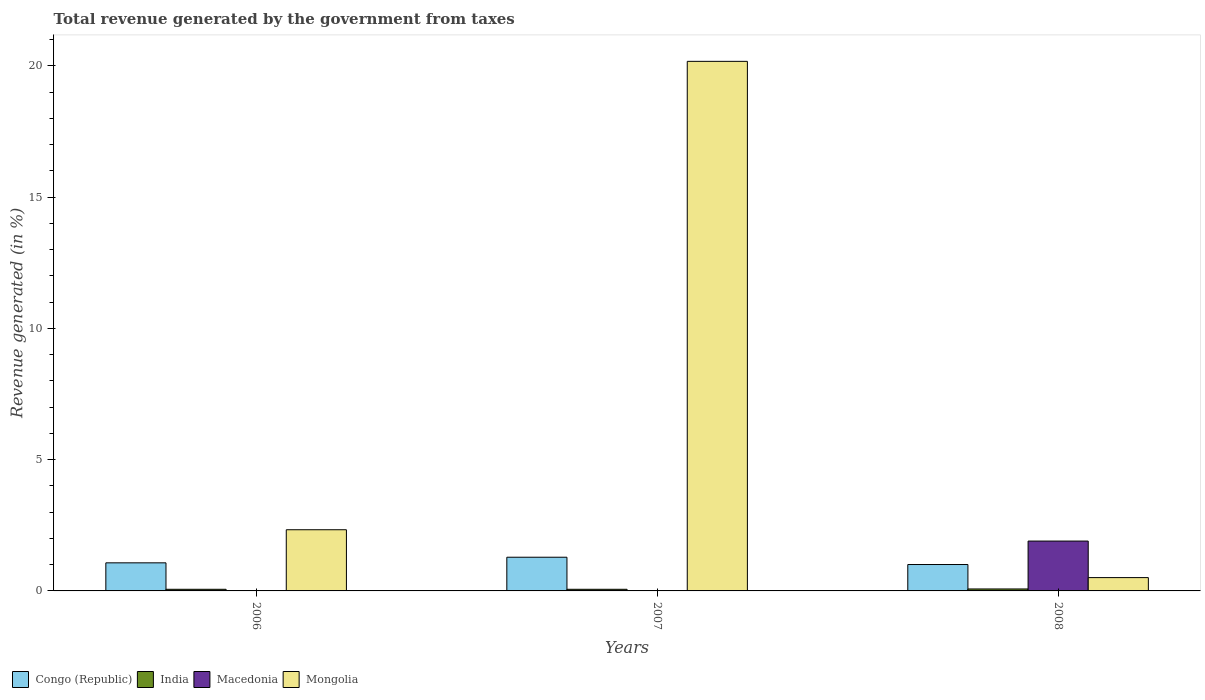How many different coloured bars are there?
Your answer should be very brief. 4. How many groups of bars are there?
Offer a very short reply. 3. Are the number of bars per tick equal to the number of legend labels?
Give a very brief answer. Yes. Are the number of bars on each tick of the X-axis equal?
Provide a succinct answer. Yes. How many bars are there on the 1st tick from the left?
Keep it short and to the point. 4. How many bars are there on the 2nd tick from the right?
Keep it short and to the point. 4. What is the label of the 3rd group of bars from the left?
Ensure brevity in your answer.  2008. What is the total revenue generated in Macedonia in 2007?
Provide a succinct answer. 0.01. Across all years, what is the maximum total revenue generated in Congo (Republic)?
Offer a terse response. 1.28. Across all years, what is the minimum total revenue generated in Mongolia?
Offer a terse response. 0.51. What is the total total revenue generated in Mongolia in the graph?
Your response must be concise. 23.01. What is the difference between the total revenue generated in Congo (Republic) in 2007 and that in 2008?
Ensure brevity in your answer.  0.28. What is the difference between the total revenue generated in Congo (Republic) in 2007 and the total revenue generated in Mongolia in 2008?
Your answer should be very brief. 0.78. What is the average total revenue generated in Congo (Republic) per year?
Your answer should be compact. 1.12. In the year 2006, what is the difference between the total revenue generated in Congo (Republic) and total revenue generated in Macedonia?
Offer a very short reply. 1.06. In how many years, is the total revenue generated in Mongolia greater than 3 %?
Offer a very short reply. 1. What is the ratio of the total revenue generated in Macedonia in 2007 to that in 2008?
Ensure brevity in your answer.  0. Is the total revenue generated in Congo (Republic) in 2006 less than that in 2008?
Provide a succinct answer. No. Is the difference between the total revenue generated in Congo (Republic) in 2007 and 2008 greater than the difference between the total revenue generated in Macedonia in 2007 and 2008?
Offer a very short reply. Yes. What is the difference between the highest and the second highest total revenue generated in Mongolia?
Offer a very short reply. 17.84. What is the difference between the highest and the lowest total revenue generated in India?
Provide a succinct answer. 0.01. In how many years, is the total revenue generated in India greater than the average total revenue generated in India taken over all years?
Make the answer very short. 1. Is it the case that in every year, the sum of the total revenue generated in Congo (Republic) and total revenue generated in Mongolia is greater than the sum of total revenue generated in India and total revenue generated in Macedonia?
Offer a very short reply. No. What does the 4th bar from the left in 2007 represents?
Give a very brief answer. Mongolia. What does the 2nd bar from the right in 2008 represents?
Provide a short and direct response. Macedonia. How many bars are there?
Keep it short and to the point. 12. Are all the bars in the graph horizontal?
Offer a very short reply. No. Are the values on the major ticks of Y-axis written in scientific E-notation?
Offer a terse response. No. Where does the legend appear in the graph?
Make the answer very short. Bottom left. How are the legend labels stacked?
Give a very brief answer. Horizontal. What is the title of the graph?
Your answer should be compact. Total revenue generated by the government from taxes. What is the label or title of the X-axis?
Offer a terse response. Years. What is the label or title of the Y-axis?
Keep it short and to the point. Revenue generated (in %). What is the Revenue generated (in %) in Congo (Republic) in 2006?
Provide a succinct answer. 1.07. What is the Revenue generated (in %) of India in 2006?
Give a very brief answer. 0.06. What is the Revenue generated (in %) in Macedonia in 2006?
Your answer should be very brief. 0.01. What is the Revenue generated (in %) of Mongolia in 2006?
Make the answer very short. 2.33. What is the Revenue generated (in %) of Congo (Republic) in 2007?
Offer a very short reply. 1.28. What is the Revenue generated (in %) of India in 2007?
Your response must be concise. 0.06. What is the Revenue generated (in %) in Macedonia in 2007?
Your answer should be compact. 0.01. What is the Revenue generated (in %) in Mongolia in 2007?
Give a very brief answer. 20.17. What is the Revenue generated (in %) of Congo (Republic) in 2008?
Offer a terse response. 1.01. What is the Revenue generated (in %) in India in 2008?
Offer a very short reply. 0.07. What is the Revenue generated (in %) of Macedonia in 2008?
Your answer should be very brief. 1.9. What is the Revenue generated (in %) in Mongolia in 2008?
Offer a very short reply. 0.51. Across all years, what is the maximum Revenue generated (in %) in Congo (Republic)?
Ensure brevity in your answer.  1.28. Across all years, what is the maximum Revenue generated (in %) of India?
Your answer should be very brief. 0.07. Across all years, what is the maximum Revenue generated (in %) in Macedonia?
Your answer should be compact. 1.9. Across all years, what is the maximum Revenue generated (in %) in Mongolia?
Give a very brief answer. 20.17. Across all years, what is the minimum Revenue generated (in %) of Congo (Republic)?
Keep it short and to the point. 1.01. Across all years, what is the minimum Revenue generated (in %) in India?
Offer a terse response. 0.06. Across all years, what is the minimum Revenue generated (in %) of Macedonia?
Make the answer very short. 0.01. Across all years, what is the minimum Revenue generated (in %) in Mongolia?
Provide a succinct answer. 0.51. What is the total Revenue generated (in %) in Congo (Republic) in the graph?
Offer a terse response. 3.36. What is the total Revenue generated (in %) in India in the graph?
Your response must be concise. 0.2. What is the total Revenue generated (in %) of Macedonia in the graph?
Your answer should be very brief. 1.91. What is the total Revenue generated (in %) of Mongolia in the graph?
Offer a very short reply. 23.01. What is the difference between the Revenue generated (in %) of Congo (Republic) in 2006 and that in 2007?
Your answer should be compact. -0.21. What is the difference between the Revenue generated (in %) of Mongolia in 2006 and that in 2007?
Ensure brevity in your answer.  -17.84. What is the difference between the Revenue generated (in %) of Congo (Republic) in 2006 and that in 2008?
Your response must be concise. 0.06. What is the difference between the Revenue generated (in %) of India in 2006 and that in 2008?
Keep it short and to the point. -0.01. What is the difference between the Revenue generated (in %) of Macedonia in 2006 and that in 2008?
Keep it short and to the point. -1.89. What is the difference between the Revenue generated (in %) of Mongolia in 2006 and that in 2008?
Keep it short and to the point. 1.82. What is the difference between the Revenue generated (in %) in Congo (Republic) in 2007 and that in 2008?
Make the answer very short. 0.28. What is the difference between the Revenue generated (in %) in India in 2007 and that in 2008?
Make the answer very short. -0.01. What is the difference between the Revenue generated (in %) of Macedonia in 2007 and that in 2008?
Ensure brevity in your answer.  -1.89. What is the difference between the Revenue generated (in %) in Mongolia in 2007 and that in 2008?
Offer a terse response. 19.66. What is the difference between the Revenue generated (in %) in Congo (Republic) in 2006 and the Revenue generated (in %) in India in 2007?
Provide a short and direct response. 1.01. What is the difference between the Revenue generated (in %) in Congo (Republic) in 2006 and the Revenue generated (in %) in Macedonia in 2007?
Make the answer very short. 1.06. What is the difference between the Revenue generated (in %) of Congo (Republic) in 2006 and the Revenue generated (in %) of Mongolia in 2007?
Your answer should be compact. -19.1. What is the difference between the Revenue generated (in %) in India in 2006 and the Revenue generated (in %) in Macedonia in 2007?
Provide a succinct answer. 0.06. What is the difference between the Revenue generated (in %) in India in 2006 and the Revenue generated (in %) in Mongolia in 2007?
Ensure brevity in your answer.  -20.11. What is the difference between the Revenue generated (in %) of Macedonia in 2006 and the Revenue generated (in %) of Mongolia in 2007?
Your answer should be very brief. -20.16. What is the difference between the Revenue generated (in %) of Congo (Republic) in 2006 and the Revenue generated (in %) of Macedonia in 2008?
Your response must be concise. -0.83. What is the difference between the Revenue generated (in %) in Congo (Republic) in 2006 and the Revenue generated (in %) in Mongolia in 2008?
Offer a very short reply. 0.56. What is the difference between the Revenue generated (in %) of India in 2006 and the Revenue generated (in %) of Macedonia in 2008?
Make the answer very short. -1.84. What is the difference between the Revenue generated (in %) in India in 2006 and the Revenue generated (in %) in Mongolia in 2008?
Provide a succinct answer. -0.45. What is the difference between the Revenue generated (in %) in Macedonia in 2006 and the Revenue generated (in %) in Mongolia in 2008?
Provide a succinct answer. -0.5. What is the difference between the Revenue generated (in %) in Congo (Republic) in 2007 and the Revenue generated (in %) in India in 2008?
Your answer should be very brief. 1.21. What is the difference between the Revenue generated (in %) in Congo (Republic) in 2007 and the Revenue generated (in %) in Macedonia in 2008?
Offer a very short reply. -0.62. What is the difference between the Revenue generated (in %) of Congo (Republic) in 2007 and the Revenue generated (in %) of Mongolia in 2008?
Offer a very short reply. 0.78. What is the difference between the Revenue generated (in %) of India in 2007 and the Revenue generated (in %) of Macedonia in 2008?
Keep it short and to the point. -1.84. What is the difference between the Revenue generated (in %) of India in 2007 and the Revenue generated (in %) of Mongolia in 2008?
Provide a succinct answer. -0.45. What is the difference between the Revenue generated (in %) of Macedonia in 2007 and the Revenue generated (in %) of Mongolia in 2008?
Provide a succinct answer. -0.5. What is the average Revenue generated (in %) in Congo (Republic) per year?
Offer a terse response. 1.12. What is the average Revenue generated (in %) of India per year?
Provide a succinct answer. 0.07. What is the average Revenue generated (in %) in Macedonia per year?
Keep it short and to the point. 0.64. What is the average Revenue generated (in %) of Mongolia per year?
Provide a succinct answer. 7.67. In the year 2006, what is the difference between the Revenue generated (in %) in Congo (Republic) and Revenue generated (in %) in India?
Offer a terse response. 1.01. In the year 2006, what is the difference between the Revenue generated (in %) in Congo (Republic) and Revenue generated (in %) in Macedonia?
Give a very brief answer. 1.06. In the year 2006, what is the difference between the Revenue generated (in %) of Congo (Republic) and Revenue generated (in %) of Mongolia?
Ensure brevity in your answer.  -1.26. In the year 2006, what is the difference between the Revenue generated (in %) in India and Revenue generated (in %) in Macedonia?
Your response must be concise. 0.06. In the year 2006, what is the difference between the Revenue generated (in %) of India and Revenue generated (in %) of Mongolia?
Offer a terse response. -2.27. In the year 2006, what is the difference between the Revenue generated (in %) of Macedonia and Revenue generated (in %) of Mongolia?
Ensure brevity in your answer.  -2.32. In the year 2007, what is the difference between the Revenue generated (in %) of Congo (Republic) and Revenue generated (in %) of India?
Your response must be concise. 1.22. In the year 2007, what is the difference between the Revenue generated (in %) in Congo (Republic) and Revenue generated (in %) in Macedonia?
Provide a succinct answer. 1.28. In the year 2007, what is the difference between the Revenue generated (in %) in Congo (Republic) and Revenue generated (in %) in Mongolia?
Your answer should be compact. -18.88. In the year 2007, what is the difference between the Revenue generated (in %) of India and Revenue generated (in %) of Macedonia?
Your answer should be very brief. 0.06. In the year 2007, what is the difference between the Revenue generated (in %) in India and Revenue generated (in %) in Mongolia?
Your answer should be very brief. -20.11. In the year 2007, what is the difference between the Revenue generated (in %) of Macedonia and Revenue generated (in %) of Mongolia?
Your answer should be very brief. -20.16. In the year 2008, what is the difference between the Revenue generated (in %) of Congo (Republic) and Revenue generated (in %) of India?
Keep it short and to the point. 0.93. In the year 2008, what is the difference between the Revenue generated (in %) of Congo (Republic) and Revenue generated (in %) of Macedonia?
Keep it short and to the point. -0.89. In the year 2008, what is the difference between the Revenue generated (in %) in Congo (Republic) and Revenue generated (in %) in Mongolia?
Offer a terse response. 0.5. In the year 2008, what is the difference between the Revenue generated (in %) of India and Revenue generated (in %) of Macedonia?
Give a very brief answer. -1.82. In the year 2008, what is the difference between the Revenue generated (in %) in India and Revenue generated (in %) in Mongolia?
Provide a succinct answer. -0.43. In the year 2008, what is the difference between the Revenue generated (in %) of Macedonia and Revenue generated (in %) of Mongolia?
Offer a terse response. 1.39. What is the ratio of the Revenue generated (in %) in Congo (Republic) in 2006 to that in 2007?
Keep it short and to the point. 0.83. What is the ratio of the Revenue generated (in %) in India in 2006 to that in 2007?
Keep it short and to the point. 1. What is the ratio of the Revenue generated (in %) in Macedonia in 2006 to that in 2007?
Offer a very short reply. 1.08. What is the ratio of the Revenue generated (in %) of Mongolia in 2006 to that in 2007?
Your answer should be very brief. 0.12. What is the ratio of the Revenue generated (in %) in Congo (Republic) in 2006 to that in 2008?
Your response must be concise. 1.06. What is the ratio of the Revenue generated (in %) in India in 2006 to that in 2008?
Your answer should be compact. 0.83. What is the ratio of the Revenue generated (in %) in Macedonia in 2006 to that in 2008?
Ensure brevity in your answer.  0. What is the ratio of the Revenue generated (in %) in Mongolia in 2006 to that in 2008?
Provide a short and direct response. 4.59. What is the ratio of the Revenue generated (in %) of Congo (Republic) in 2007 to that in 2008?
Your answer should be very brief. 1.28. What is the ratio of the Revenue generated (in %) in India in 2007 to that in 2008?
Your answer should be very brief. 0.83. What is the ratio of the Revenue generated (in %) in Macedonia in 2007 to that in 2008?
Give a very brief answer. 0. What is the ratio of the Revenue generated (in %) in Mongolia in 2007 to that in 2008?
Keep it short and to the point. 39.75. What is the difference between the highest and the second highest Revenue generated (in %) of Congo (Republic)?
Make the answer very short. 0.21. What is the difference between the highest and the second highest Revenue generated (in %) in India?
Offer a terse response. 0.01. What is the difference between the highest and the second highest Revenue generated (in %) of Macedonia?
Make the answer very short. 1.89. What is the difference between the highest and the second highest Revenue generated (in %) of Mongolia?
Offer a terse response. 17.84. What is the difference between the highest and the lowest Revenue generated (in %) in Congo (Republic)?
Make the answer very short. 0.28. What is the difference between the highest and the lowest Revenue generated (in %) in India?
Give a very brief answer. 0.01. What is the difference between the highest and the lowest Revenue generated (in %) of Macedonia?
Your answer should be very brief. 1.89. What is the difference between the highest and the lowest Revenue generated (in %) of Mongolia?
Keep it short and to the point. 19.66. 